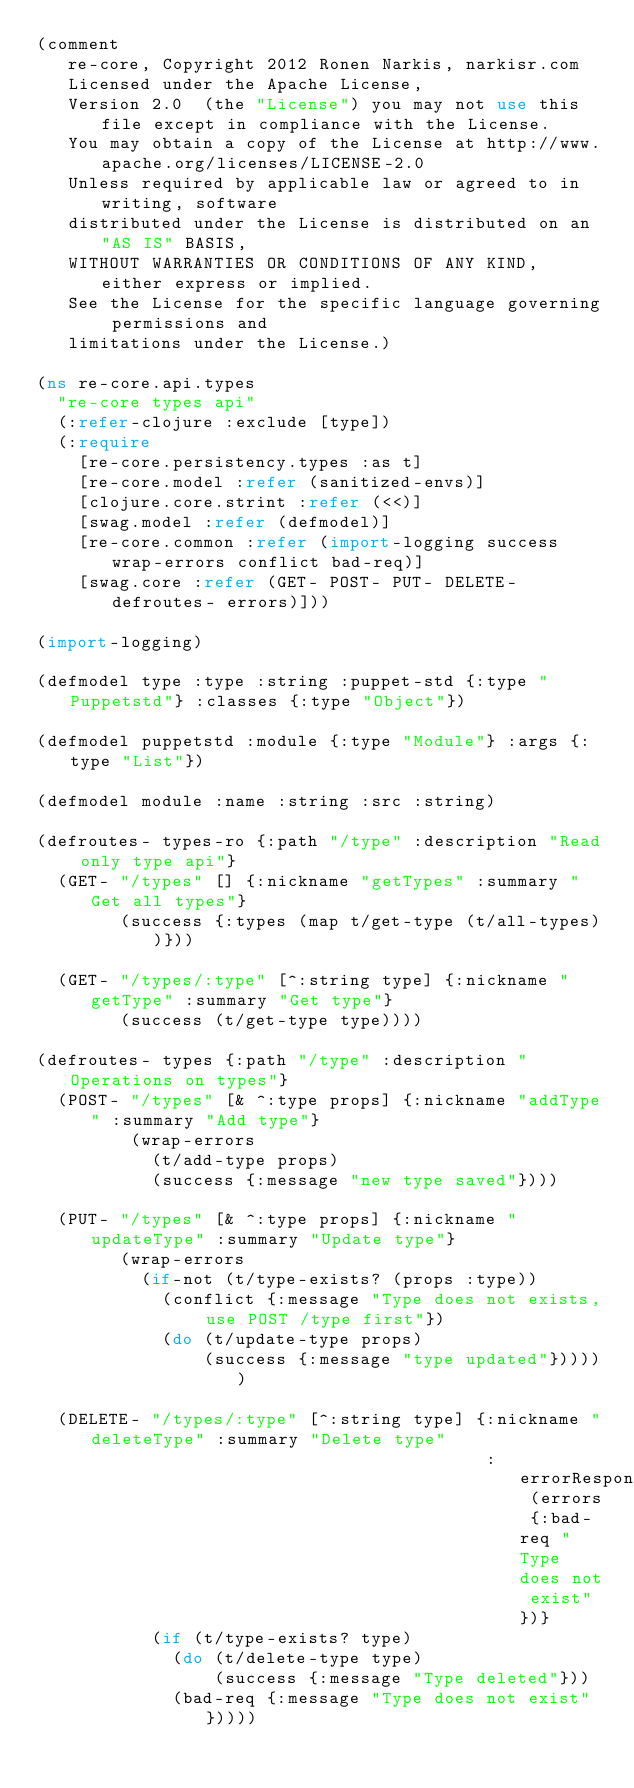<code> <loc_0><loc_0><loc_500><loc_500><_Clojure_>(comment 
   re-core, Copyright 2012 Ronen Narkis, narkisr.com
   Licensed under the Apache License,
   Version 2.0  (the "License") you may not use this file except in compliance with the License.
   You may obtain a copy of the License at http://www.apache.org/licenses/LICENSE-2.0
   Unless required by applicable law or agreed to in writing, software
   distributed under the License is distributed on an "AS IS" BASIS,
   WITHOUT WARRANTIES OR CONDITIONS OF ANY KIND, either express or implied.
   See the License for the specific language governing permissions and
   limitations under the License.)

(ns re-core.api.types
  "re-core types api"
  (:refer-clojure :exclude [type])
  (:require 
    [re-core.persistency.types :as t]
    [re-core.model :refer (sanitized-envs)]
    [clojure.core.strint :refer (<<)]
    [swag.model :refer (defmodel)]
    [re-core.common :refer (import-logging success wrap-errors conflict bad-req)]
    [swag.core :refer (GET- POST- PUT- DELETE- defroutes- errors)]))

(import-logging)

(defmodel type :type :string :puppet-std {:type "Puppetstd"} :classes {:type "Object"})

(defmodel puppetstd :module {:type "Module"} :args {:type "List"})

(defmodel module :name :string :src :string)

(defroutes- types-ro {:path "/type" :description "Read only type api"}
  (GET- "/types" [] {:nickname "getTypes" :summary "Get all types"}
        (success {:types (map t/get-type (t/all-types))}))

  (GET- "/types/:type" [^:string type] {:nickname "getType" :summary "Get type"}
        (success (t/get-type type))))

(defroutes- types {:path "/type" :description "Operations on types"}
  (POST- "/types" [& ^:type props] {:nickname "addType" :summary "Add type"}
         (wrap-errors 
           (t/add-type props)
           (success {:message "new type saved"})))

  (PUT- "/types" [& ^:type props] {:nickname "updateType" :summary "Update type"}
        (wrap-errors
          (if-not (t/type-exists? (props :type))
            (conflict {:message "Type does not exists, use POST /type first"}) 
            (do (t/update-type props) 
                (success {:message "type updated"})))))

  (DELETE- "/types/:type" [^:string type] {:nickname "deleteType" :summary "Delete type" 
                                           :errorResponses (errors {:bad-req "Type does not exist"})}
           (if (t/type-exists? type)
             (do (t/delete-type type) 
                 (success {:message "Type deleted"}))
             (bad-req {:message "Type does not exist"}))))
 
</code> 